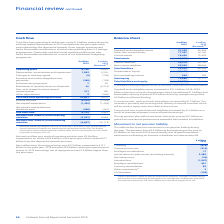According to Unilever Plc's financial document, What caused the increase in the cash flow from operating activities in 2019? mainly driven by working capital improvement in 2019 compared to the prior year which was impacted by the disposal of spreads. The document states: "from operating activities was up by €1.0 billion mainly driven by working capital improvement in 2019 compared to the prior year which was impacted by..." Also, What contributed to the Gross Profit margin improvement? a result of strong delivery from 5-S savings programmes. The document states: "margin improvement had a favourable contribution a result of strong delivery from 5-S savings programmes. Overheads and brand and marketing efficienci..." Also, What constituted the cash inflow from investing activities in 2018? included €7.1 billion from the disposal of spreads business. The document states: "an inflow of €4.6 billion in the prior year which included €7.1 billion from the disposal of spreads business...." Also, can you calculate: What is the change in the operating profit?  Based on the calculation: 8,708 - 12,639, the result is -3931 (in thousands). This is based on the information: "Operating profit 8,708 12,639 Operating profit 8,708 12,639..." The key data points involved are: 12,639, 8,708. Also, can you calculate: What is the increase / (decrease) in the Free Cash Flow? Based on the calculation: 6,132 - 5,433, the result is 699 (in thousands). This is based on the information: "Free cash flow* 6,132 5,433 Free cash flow* 6,132 5,433..." The key data points involved are: 5,433, 6,132. Also, can you calculate: What is the average Depreciation, amortisation and impairment? To answer this question, I need to perform calculations using the financial data. The calculation is: (1,982 + 2,216) / 2, which equals 2099 (in thousands). This is based on the information: "Depreciation, amortisation and impairment 1,982 2,216 Depreciation, amortisation and impairment 1,982 2,216..." The key data points involved are: 1,982, 2,216. 